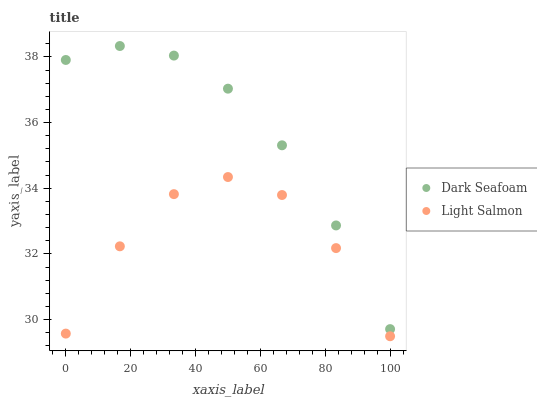Does Light Salmon have the minimum area under the curve?
Answer yes or no. Yes. Does Dark Seafoam have the maximum area under the curve?
Answer yes or no. Yes. Does Light Salmon have the maximum area under the curve?
Answer yes or no. No. Is Dark Seafoam the smoothest?
Answer yes or no. Yes. Is Light Salmon the roughest?
Answer yes or no. Yes. Is Light Salmon the smoothest?
Answer yes or no. No. Does Light Salmon have the lowest value?
Answer yes or no. Yes. Does Dark Seafoam have the highest value?
Answer yes or no. Yes. Does Light Salmon have the highest value?
Answer yes or no. No. Is Light Salmon less than Dark Seafoam?
Answer yes or no. Yes. Is Dark Seafoam greater than Light Salmon?
Answer yes or no. Yes. Does Light Salmon intersect Dark Seafoam?
Answer yes or no. No. 